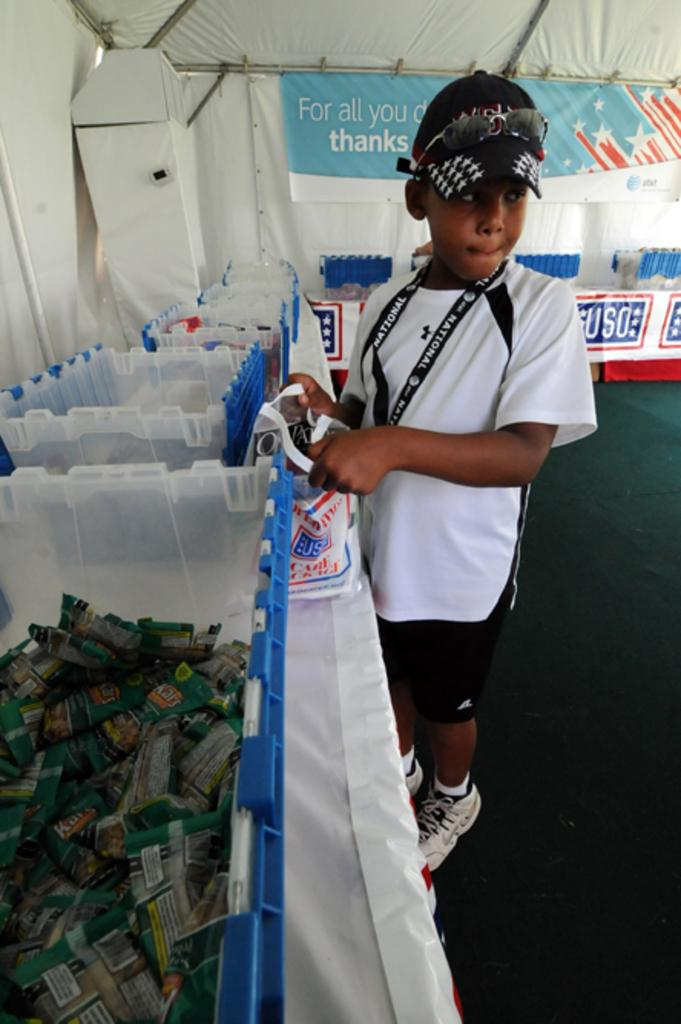Who is present in the image? There is a boy in the image. What is the boy wearing on his upper body? The boy is wearing a white t-shirt. What is the boy wearing on his head? The boy is wearing a black cap. What is the boy holding in his hand? The boy is holding a carry bag in his hand. What can be seen in the background of the image? There is a tent and containers in the background of the image. How many trees are visible in the image? There are no trees visible in the image. What type of beast can be seen interacting with the boy in the image? There is no beast present in the image; only the boy, his clothing, and the background elements are visible. 